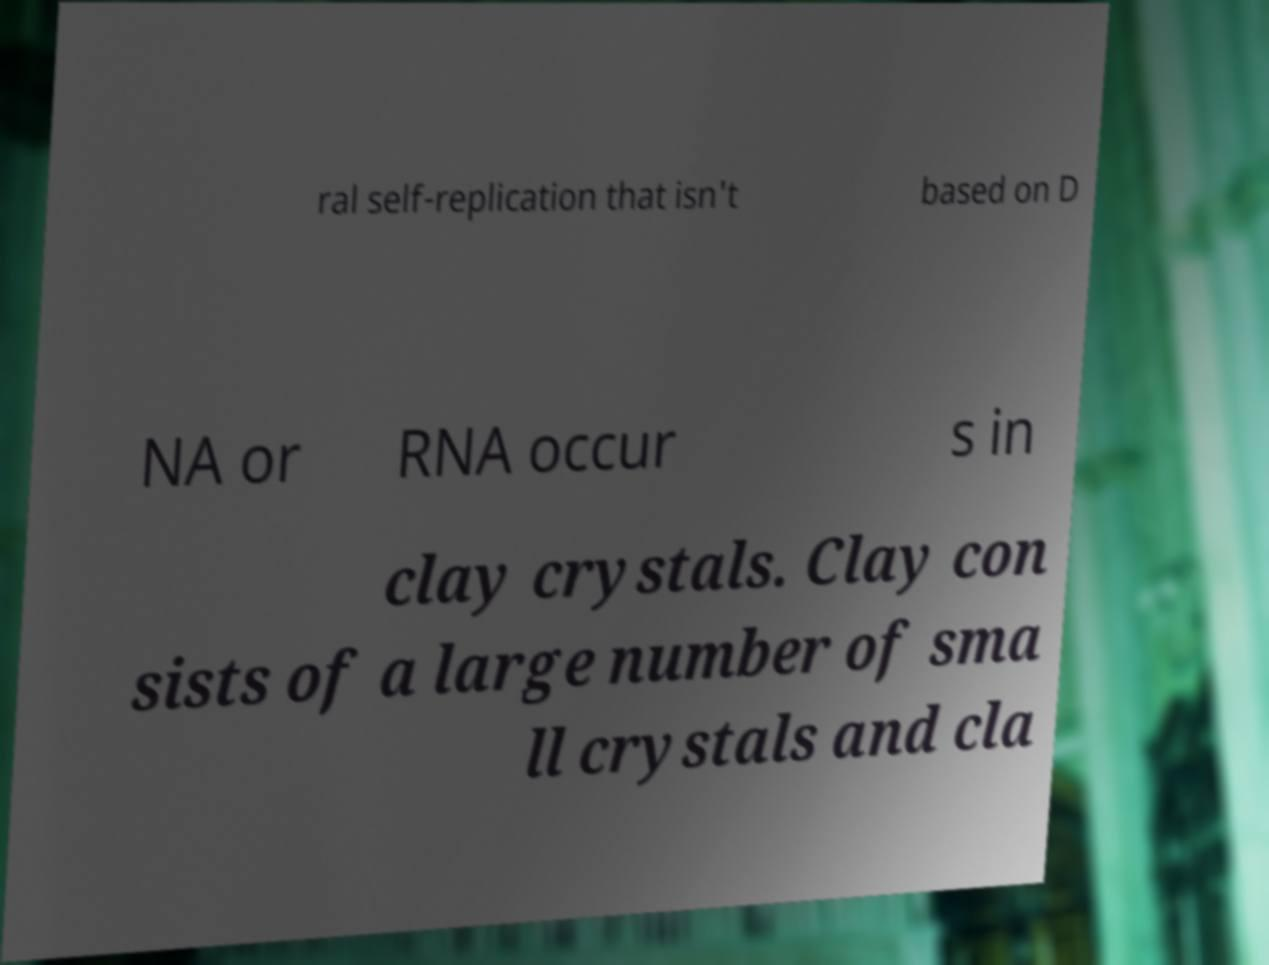Can you accurately transcribe the text from the provided image for me? ral self-replication that isn't based on D NA or RNA occur s in clay crystals. Clay con sists of a large number of sma ll crystals and cla 